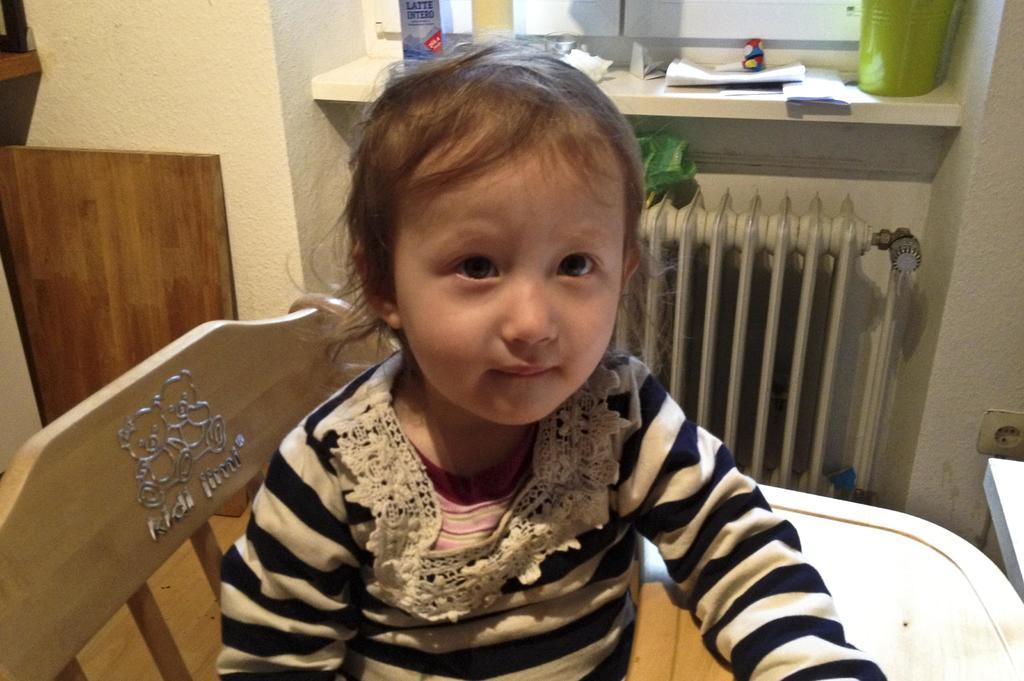What is the main subject in the foreground of the image? There is a kid in the foreground of the image. What is the kid doing in the image? The kid is sitting on a chair. What can be seen in the background of the image? There is a wooden plank, a wall, a box, papers, and pipes-like structures in the background of the image. Is there a stranger with a flame and a bomb in the image? No, there is no stranger, flame, or bomb present in the image. 